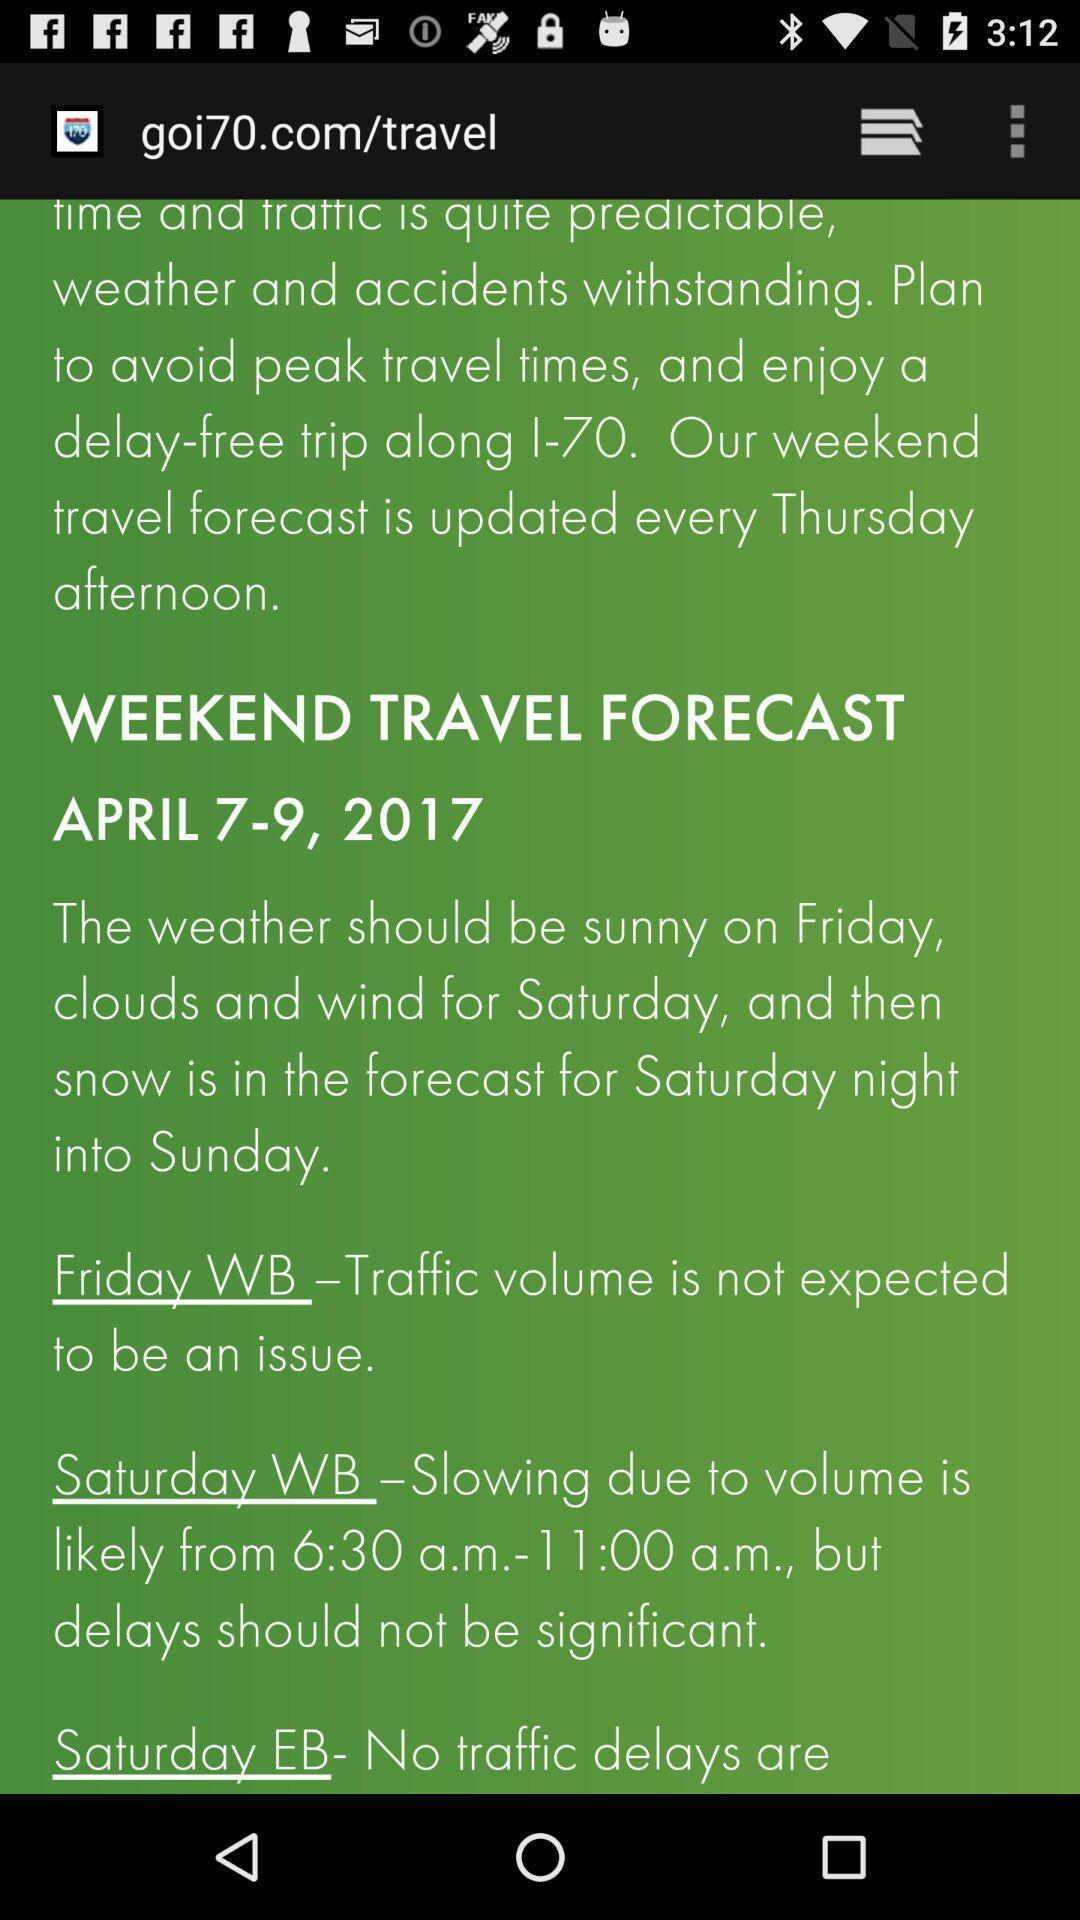How many days are there in the forecast?
Answer the question using a single word or phrase. 3 